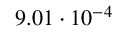<formula> <loc_0><loc_0><loc_500><loc_500>9 . 0 1 \cdot 1 0 ^ { - 4 }</formula> 